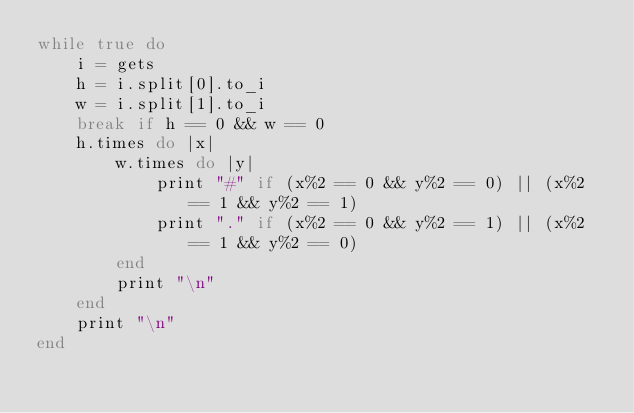<code> <loc_0><loc_0><loc_500><loc_500><_Ruby_>while true do
    i = gets
    h = i.split[0].to_i
    w = i.split[1].to_i
    break if h == 0 && w == 0
    h.times do |x|
        w.times do |y|
            print "#" if (x%2 == 0 && y%2 == 0) || (x%2 == 1 && y%2 == 1)
            print "." if (x%2 == 0 && y%2 == 1) || (x%2 == 1 && y%2 == 0)
        end
        print "\n"
    end
    print "\n"
end

</code> 